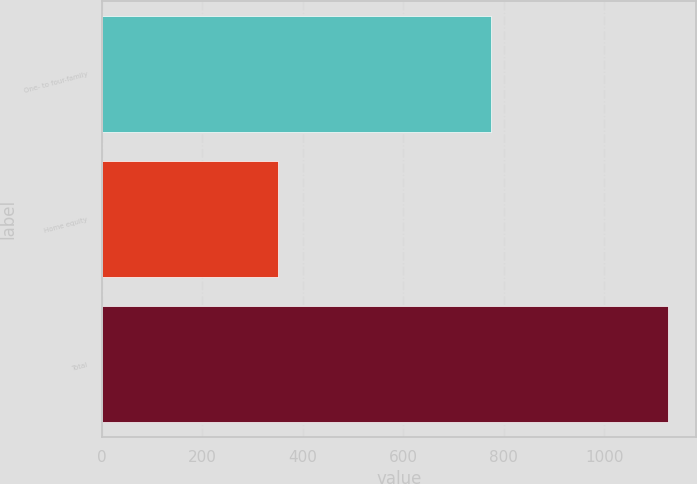Convert chart to OTSL. <chart><loc_0><loc_0><loc_500><loc_500><bar_chart><fcel>One- to four-family<fcel>Home equity<fcel>Total<nl><fcel>774<fcel>351.6<fcel>1125.6<nl></chart> 